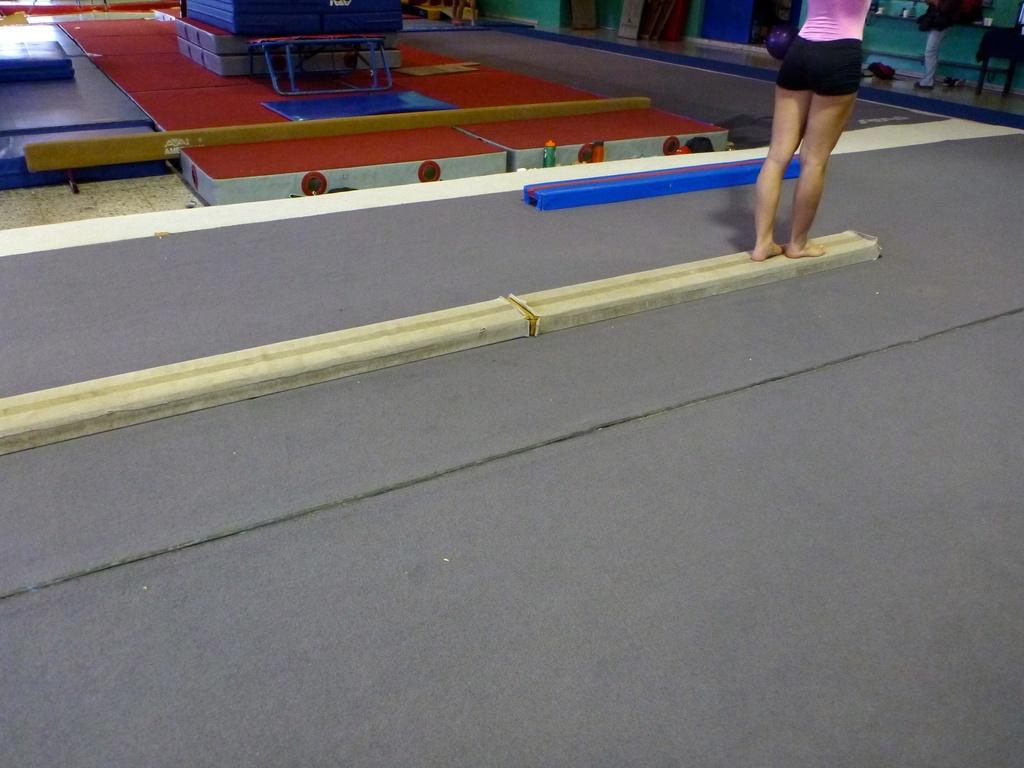What can be seen in the image that belongs to people? There are legs of persons in the image. What type of flooring is present in the image? There is a carpet in the image. What objects are visible in the image that are not related to people? There are boxes in the image. What type of zephyr can be seen blowing through the image? There is no zephyr present in the image; it is a term for a gentle breeze, and there is no indication of wind in the image. 